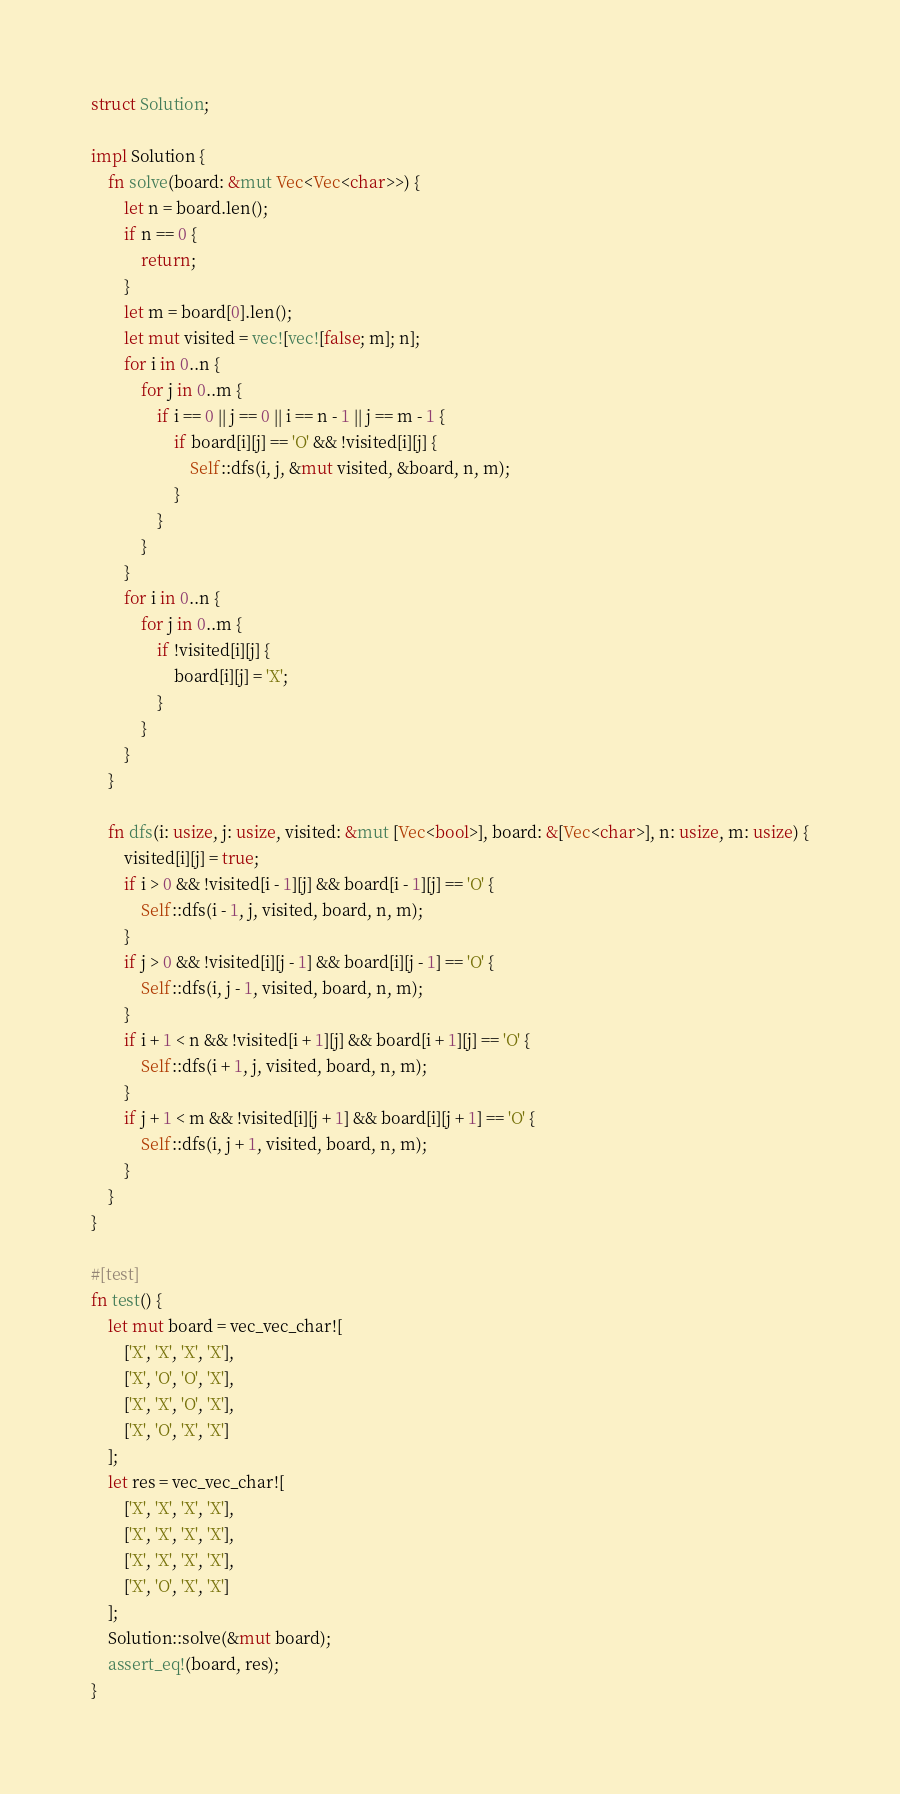Convert code to text. <code><loc_0><loc_0><loc_500><loc_500><_Rust_>struct Solution;

impl Solution {
    fn solve(board: &mut Vec<Vec<char>>) {
        let n = board.len();
        if n == 0 {
            return;
        }
        let m = board[0].len();
        let mut visited = vec![vec![false; m]; n];
        for i in 0..n {
            for j in 0..m {
                if i == 0 || j == 0 || i == n - 1 || j == m - 1 {
                    if board[i][j] == 'O' && !visited[i][j] {
                        Self::dfs(i, j, &mut visited, &board, n, m);
                    }
                }
            }
        }
        for i in 0..n {
            for j in 0..m {
                if !visited[i][j] {
                    board[i][j] = 'X';
                }
            }
        }
    }

    fn dfs(i: usize, j: usize, visited: &mut [Vec<bool>], board: &[Vec<char>], n: usize, m: usize) {
        visited[i][j] = true;
        if i > 0 && !visited[i - 1][j] && board[i - 1][j] == 'O' {
            Self::dfs(i - 1, j, visited, board, n, m);
        }
        if j > 0 && !visited[i][j - 1] && board[i][j - 1] == 'O' {
            Self::dfs(i, j - 1, visited, board, n, m);
        }
        if i + 1 < n && !visited[i + 1][j] && board[i + 1][j] == 'O' {
            Self::dfs(i + 1, j, visited, board, n, m);
        }
        if j + 1 < m && !visited[i][j + 1] && board[i][j + 1] == 'O' {
            Self::dfs(i, j + 1, visited, board, n, m);
        }
    }
}

#[test]
fn test() {
    let mut board = vec_vec_char![
        ['X', 'X', 'X', 'X'],
        ['X', 'O', 'O', 'X'],
        ['X', 'X', 'O', 'X'],
        ['X', 'O', 'X', 'X']
    ];
    let res = vec_vec_char![
        ['X', 'X', 'X', 'X'],
        ['X', 'X', 'X', 'X'],
        ['X', 'X', 'X', 'X'],
        ['X', 'O', 'X', 'X']
    ];
    Solution::solve(&mut board);
    assert_eq!(board, res);
}
</code> 